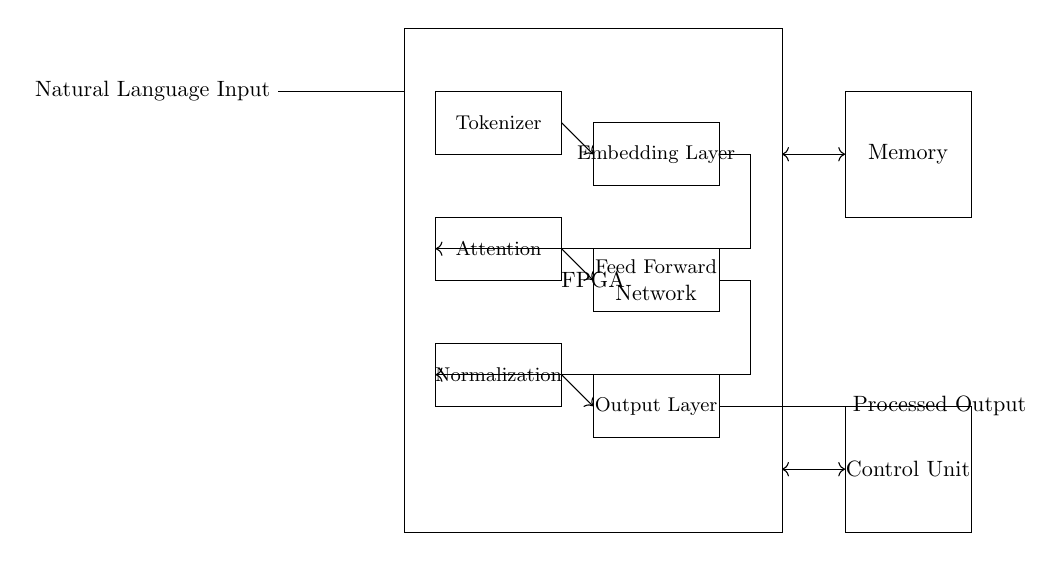What is the main component in this circuit? The main component is the FPGA, which is indicated in the diagram as a rectangle enclosing other elements. It serves as the hardware accelerator for processing natural language input.
Answer: FPGA What type of layer is labeled above the embedding layer? The layer above the embedding layer is the tokenizer, which is responsible for converting natural language input into a format suitable for further processing in the FPGA.
Answer: Tokenizer How does the output layer connect to the normalization layer? The output layer connects to the normalization layer through an arrow indicating a unidirectional flow of processed information, showing the sequence of operations from the output back to normalization.
Answer: Arrow What is the purpose of the control unit in this circuit? The control unit coordinates the operation of different components within the circuit, ensuring the correct sequence and timing of all processes involved in natural language processing.
Answer: Coordination Which component is responsible for memory storage? The memory component is indicated in the diagram as a separate rectangle labeled "Memory," representing the storage area for intermediate or final results.
Answer: Memory What sequence of operations occurs before reaching the output layer? The sequence of operations from tokenizer to embedding layer, followed by attention, feed forward network, and normalization culminates in the output layer, indicating a multi-step processing flow.
Answer: Tokenizer, Embedding Layer, Attention, Feed Forward Network, Normalization What are the two main inputs to the FPGA in this circuit? The two main inputs to the FPGA are the natural language input and the control signals from the control unit, as shown by the connections to the FPGA.
Answer: Natural Language Input, Control Signals 